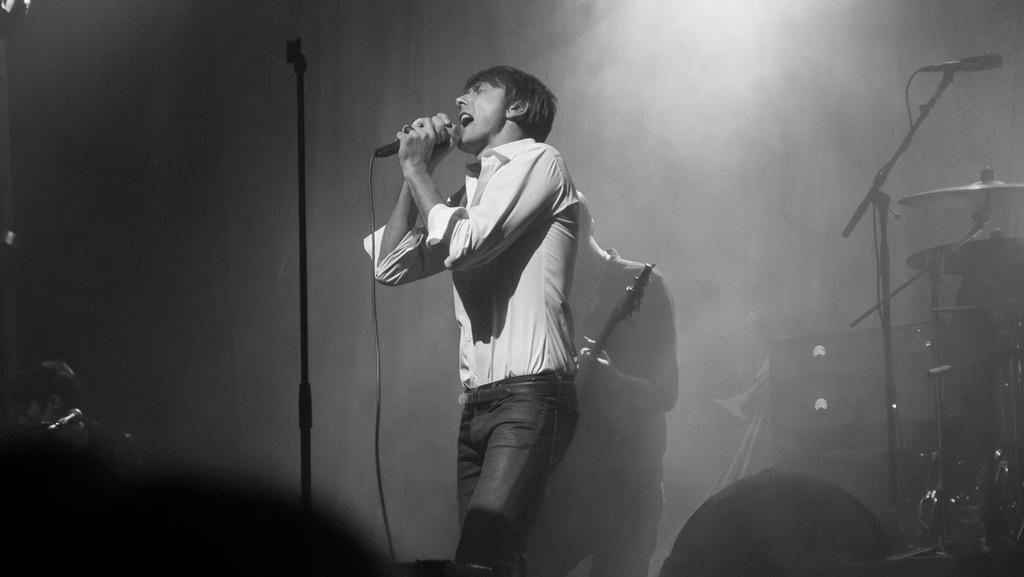What is the man in the image doing? The man is holding a microphone in his hand and singing. What other person is present in the image? There is a person playing a guitar in the image. What musical instrument can be seen in the image besides the guitar? There are drums visible in the image. How would you describe the lighting in the image? The image appears to be dark. How many goldfish are swimming in the background of the image? There are no goldfish present in the image; it features a man singing and a person playing a guitar. What type of distribution is being used for the musical instruments in the image? There is no mention of a specific distribution for the musical instruments in the image; they are simply visible in the scene. 